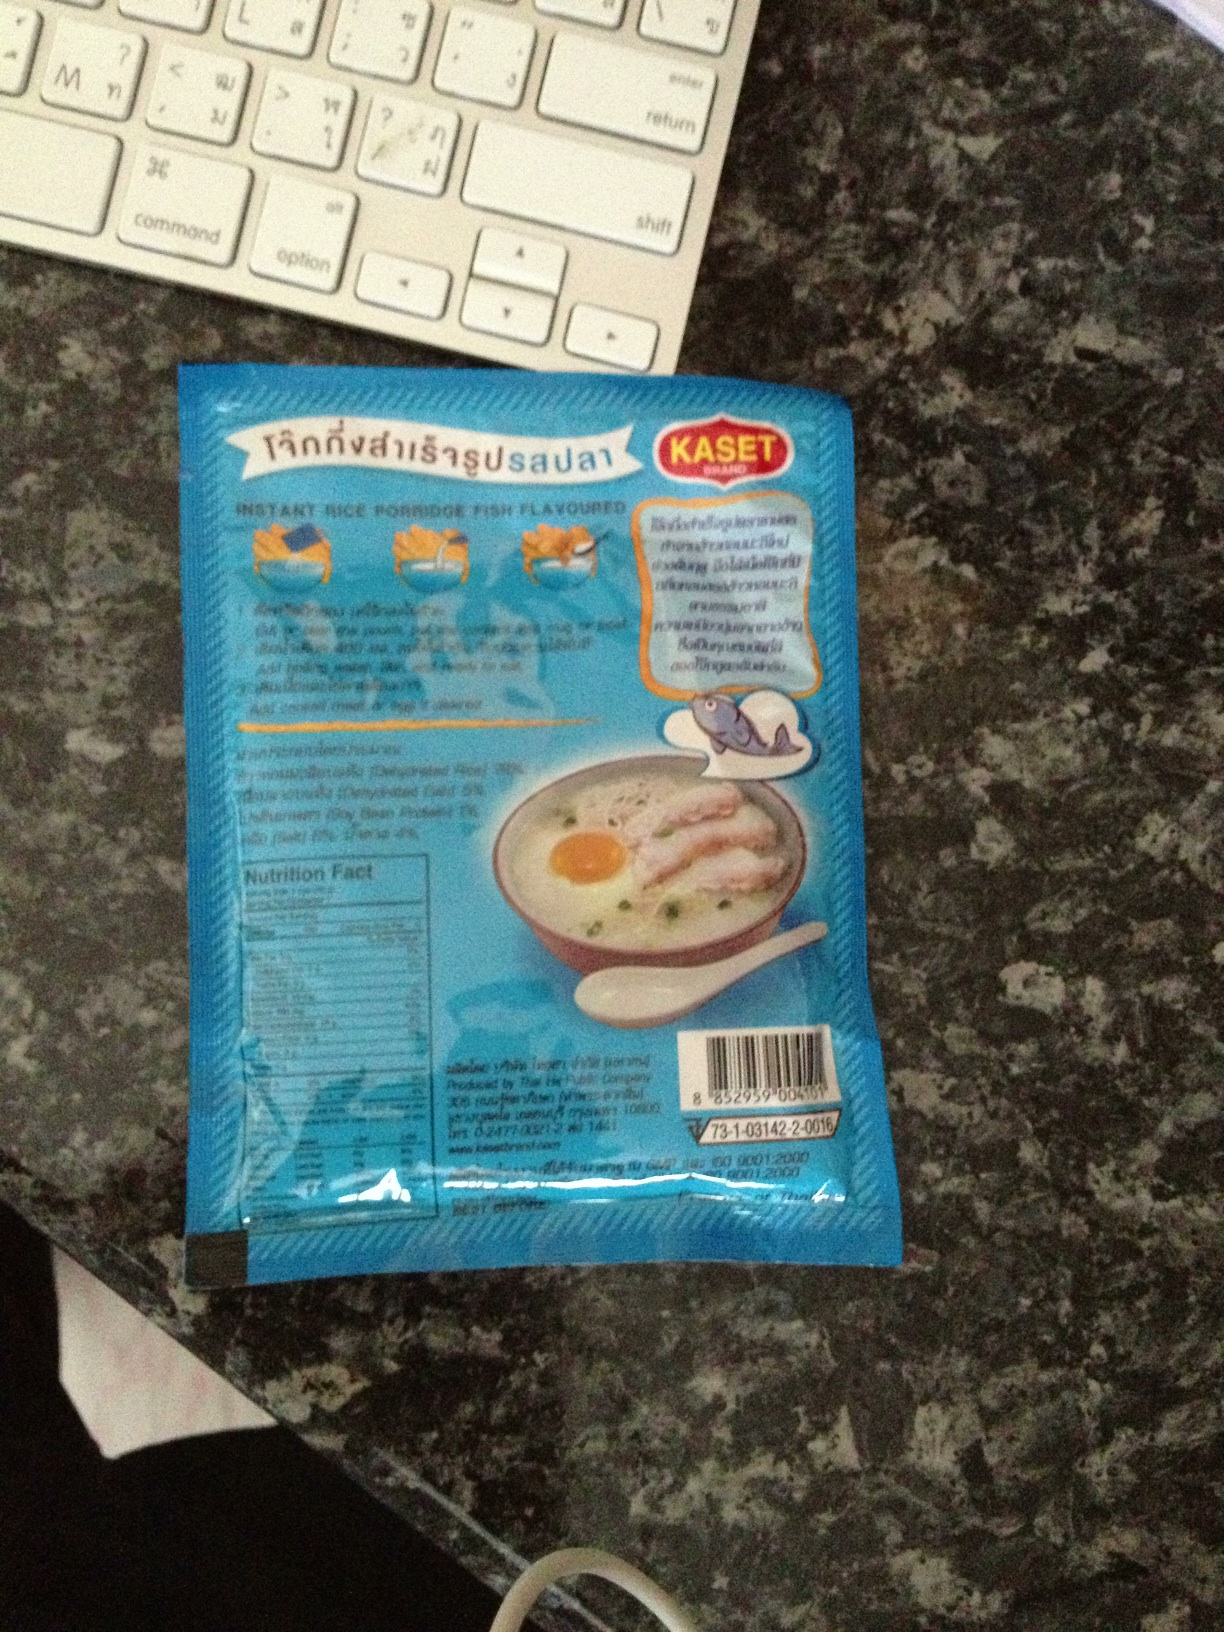What flavor is this rice porridge? The packaging indicates that this is an instant rice porridge with fish flavor. The details about the specific type of fish used or the style of flavoring are not visible from the image. 